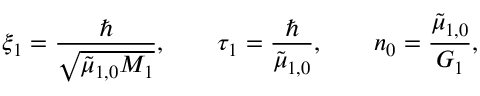<formula> <loc_0><loc_0><loc_500><loc_500>\xi _ { 1 } = \frac { } { \sqrt { { \tilde { \mu } _ { 1 , 0 } } M _ { 1 } } } , \quad \tau _ { 1 } = \frac { } { { \tilde { \mu } _ { 1 , 0 } } } , \quad n _ { 0 } = \frac { { \tilde { \mu } _ { 1 , 0 } } } { G _ { 1 } } ,</formula> 